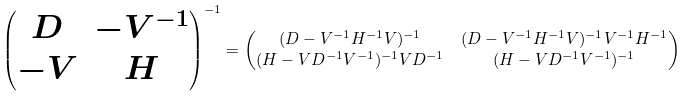<formula> <loc_0><loc_0><loc_500><loc_500>\begin{pmatrix} D & - V ^ { - 1 } \\ - V & H \end{pmatrix} ^ { - 1 } & = \begin{pmatrix} ( D - V ^ { - 1 } H ^ { - 1 } V ) ^ { - 1 } & ( D - V ^ { - 1 } H ^ { - 1 } V ) ^ { - 1 } V ^ { - 1 } H ^ { - 1 } \\ ( H - V D ^ { - 1 } V ^ { - 1 } ) ^ { - 1 } V D ^ { - 1 } & ( H - V D ^ { - 1 } V ^ { - 1 } ) ^ { - 1 } \end{pmatrix}</formula> 